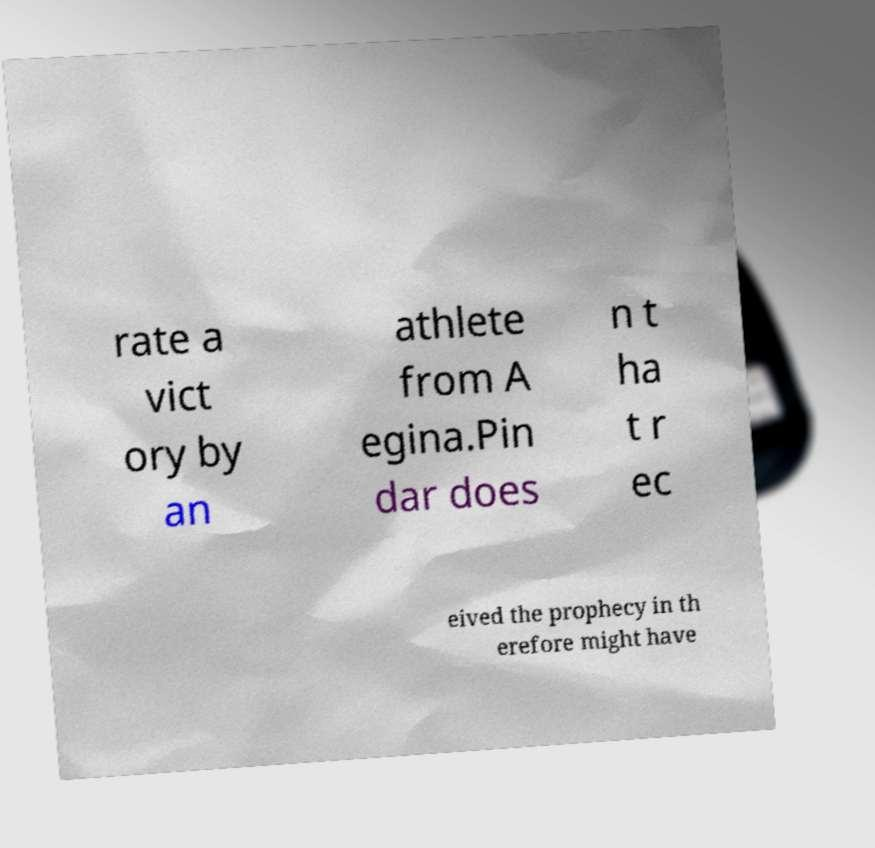There's text embedded in this image that I need extracted. Can you transcribe it verbatim? rate a vict ory by an athlete from A egina.Pin dar does n t ha t r ec eived the prophecy in th erefore might have 